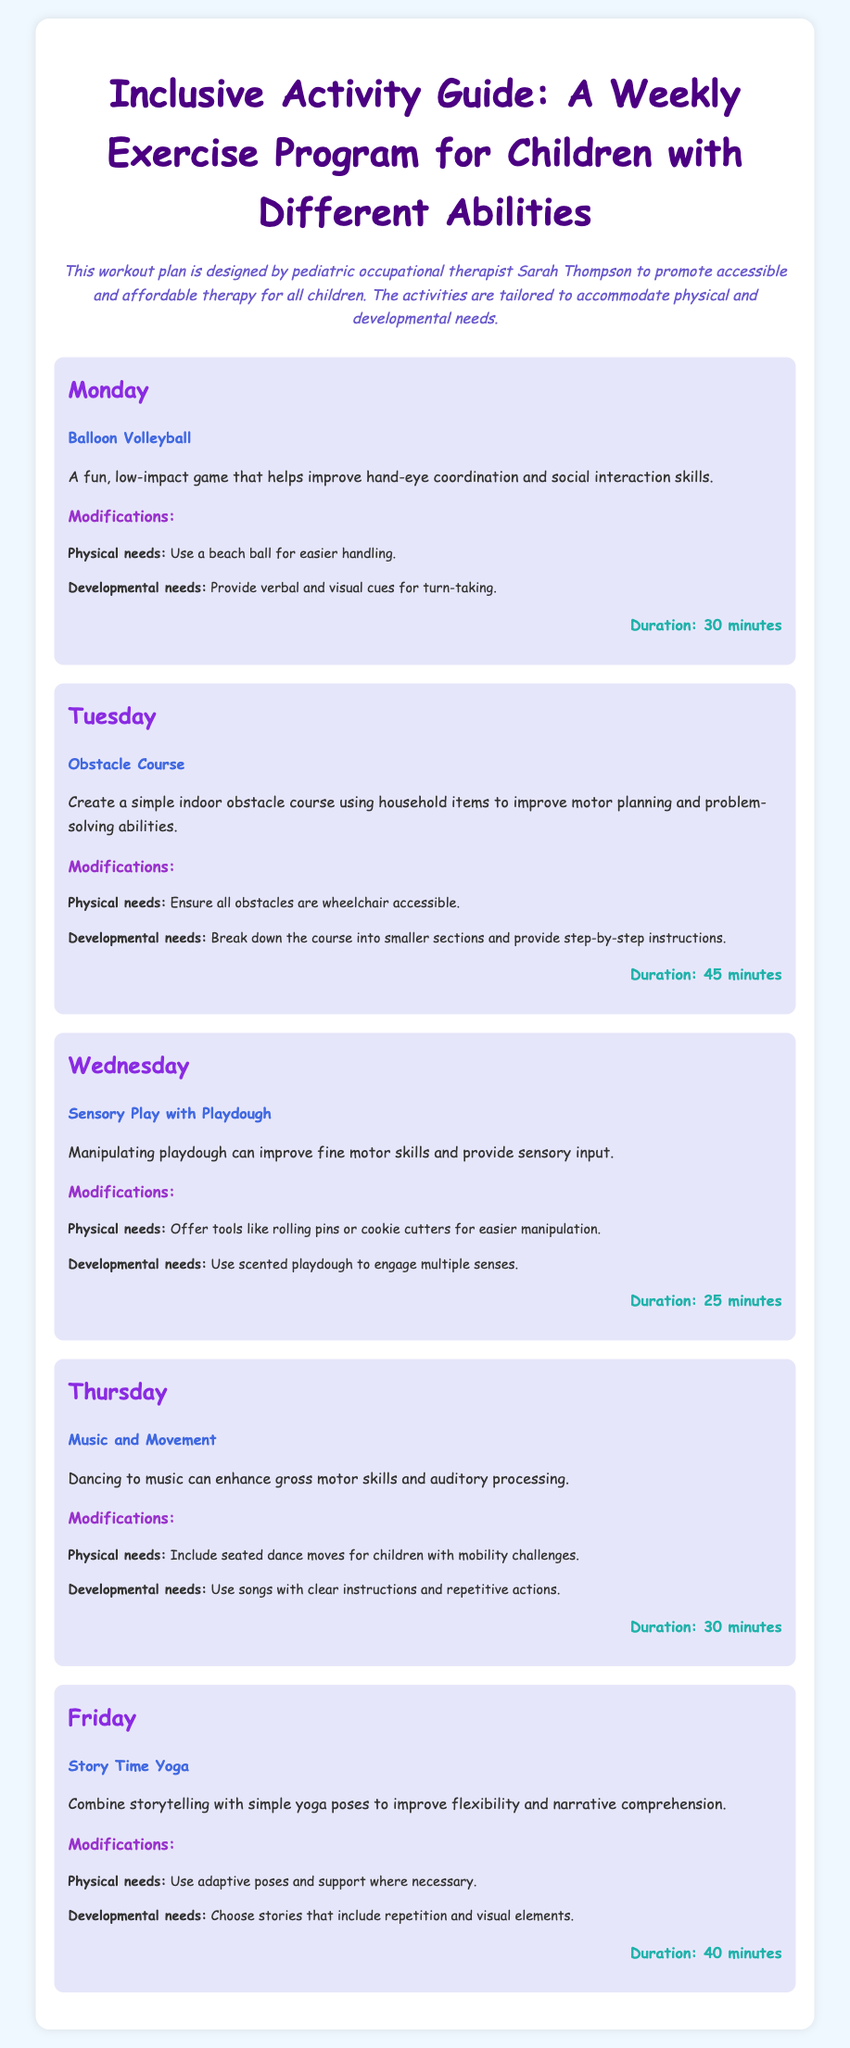What is the title of the document? The title of the document is indicated at the top and is "Inclusive Activity Guide: A Weekly Exercise Program for Children with Different Abilities".
Answer: Inclusive Activity Guide: A Weekly Exercise Program for Children with Different Abilities Who designed this workout plan? The document attributes the design of the workout plan to a specific individual mentioned in the description.
Answer: Sarah Thompson What activity is scheduled for Wednesday? The activity listed for Wednesday is mentioned in the corresponding section of the document.
Answer: Sensory Play with Playdough How long is the duration of the Obstacle Course activity? The duration of the Obstacle Course is specified in the section detailing that particular activity.
Answer: 45 minutes What modification is suggested for children with mobility challenges during Music and Movement? The suggested modification for children with mobility challenges is noted under the Music and Movement activity section.
Answer: Include seated dance moves How many total activities are outlined in the guide? The total number of activities can be counted from the sections provided in the document.
Answer: Five What is the focus of the Story Time Yoga activity? The focus of the Story Time Yoga is specified in the description of the activity in the document.
Answer: Improve flexibility and narrative comprehension Which day features Balloon Volleyball? The day when Balloon Volleyball is scheduled is stated clearly in its designated section.
Answer: Monday What type of cues are recommended for developmental needs in Balloon Volleyball? The recommended cues for developmental needs are mentioned under the modifications for the Balloon Volleyball activity.
Answer: Verbal and visual cues 